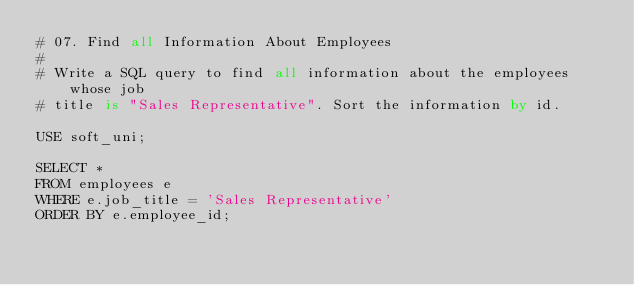<code> <loc_0><loc_0><loc_500><loc_500><_SQL_>#	07. Find all Information About Employees
#
# Write a SQL query to find all information about the employees whose job
# title is "Sales Representative". Sort the information by id.

USE soft_uni;

SELECT *
FROM employees e
WHERE e.job_title = 'Sales Representative'
ORDER BY e.employee_id;</code> 